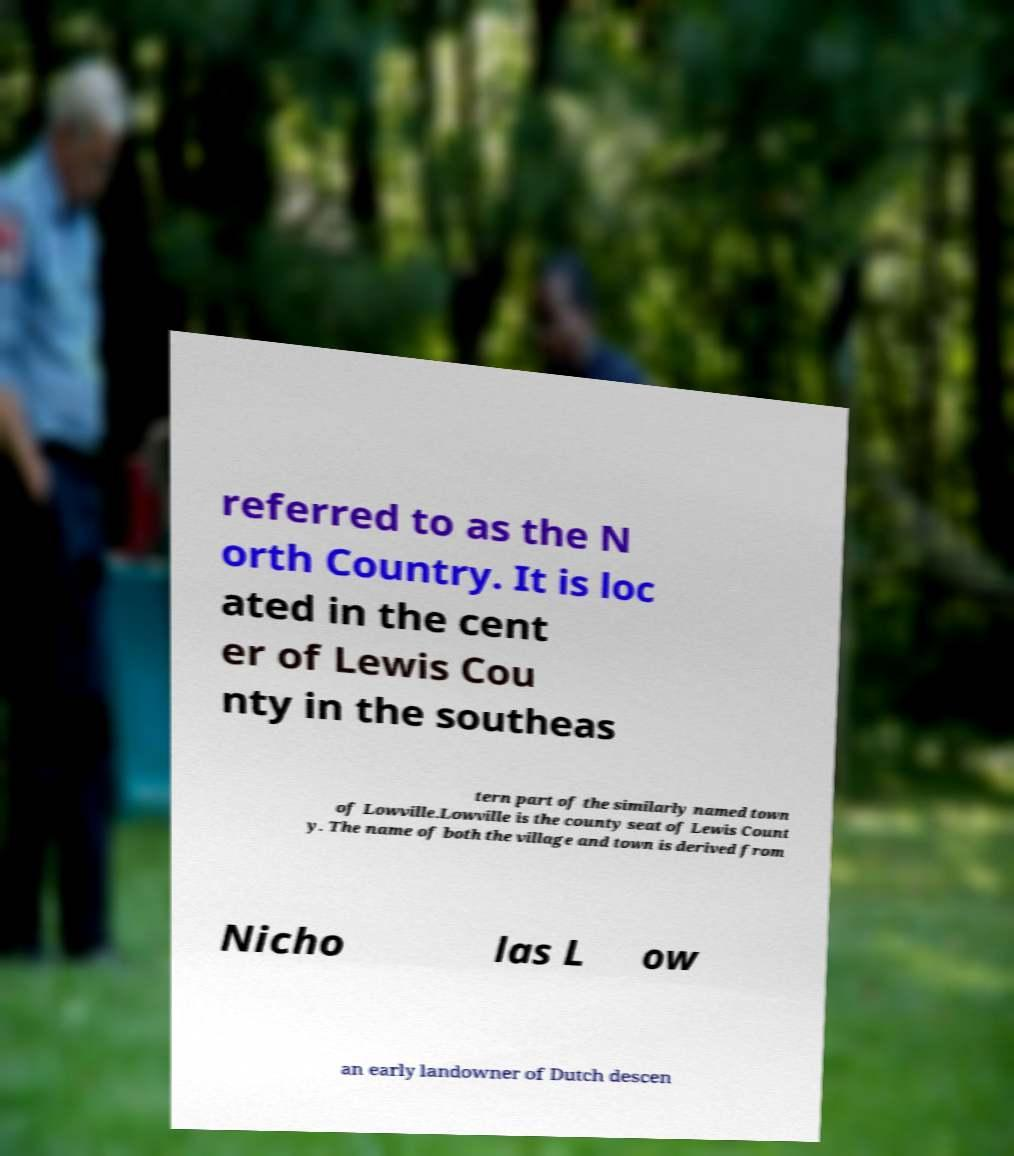Please identify and transcribe the text found in this image. referred to as the N orth Country. It is loc ated in the cent er of Lewis Cou nty in the southeas tern part of the similarly named town of Lowville.Lowville is the county seat of Lewis Count y. The name of both the village and town is derived from Nicho las L ow an early landowner of Dutch descen 